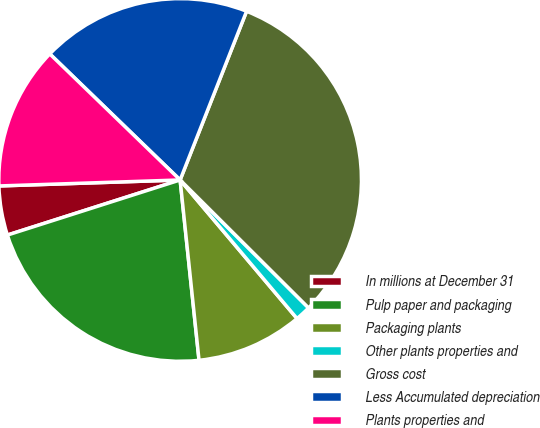Convert chart to OTSL. <chart><loc_0><loc_0><loc_500><loc_500><pie_chart><fcel>In millions at December 31<fcel>Pulp paper and packaging<fcel>Packaging plants<fcel>Other plants properties and<fcel>Gross cost<fcel>Less Accumulated depreciation<fcel>Plants properties and<nl><fcel>4.39%<fcel>21.75%<fcel>9.49%<fcel>1.38%<fcel>31.5%<fcel>18.74%<fcel>12.76%<nl></chart> 